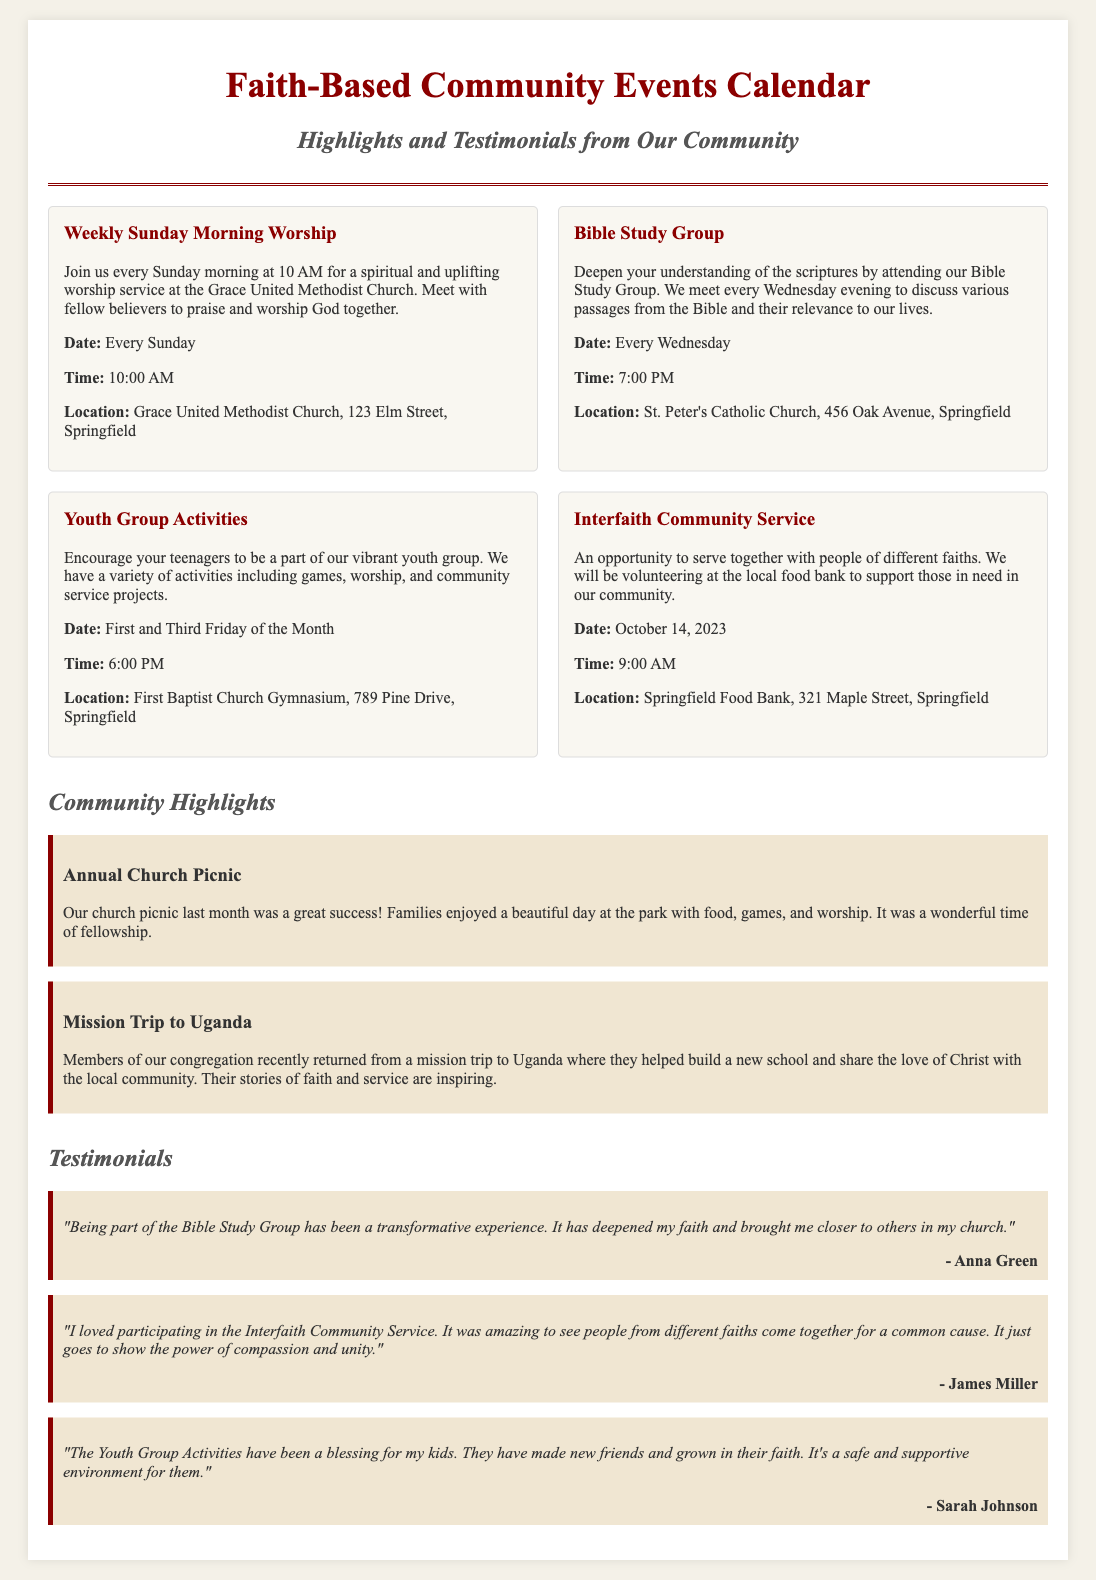what time does the Weekly Sunday Morning Worship start? The Weekly Sunday Morning Worship starts at 10 AM, as stated in the document.
Answer: 10 AM where is the Youth Group Activities held? The Youth Group Activities are held at the First Baptist Church Gymnasium, which is mentioned in the event details.
Answer: First Baptist Church Gymnasium what date is the Interfaith Community Service scheduled for? The Interfaith Community Service is scheduled for October 14, 2023, as provided in the document.
Answer: October 14, 2023 what type of event is highlighted in the Community Highlights section regarding Uganda? The highlighted event in the Community Highlights section is a Mission Trip, which involved building a new school.
Answer: Mission Trip who gave a testimonial about the Bible Study Group? The testimonial about the Bible Study Group was given by Anna Green, as noted in the testimonials section.
Answer: Anna Green how often does the Bible Study Group meet? The Bible Study Group meets every Wednesday evening, as detailed in the event description.
Answer: Every Wednesday which church is located at 456 Oak Avenue? The church located at 456 Oak Avenue is St. Peter's Catholic Church, as mentioned in the event details.
Answer: St. Peter's Catholic Church what is a key benefit mentioned in the Youth Group Activities testimonial? The key benefit mentioned is that the kids have made new friends and grown in their faith, highlighted in the testimonial.
Answer: Made new friends and grown in their faith what color is used for the background of the document? The background color of the document is a light beige, specifically noted in the style section.
Answer: Light beige 